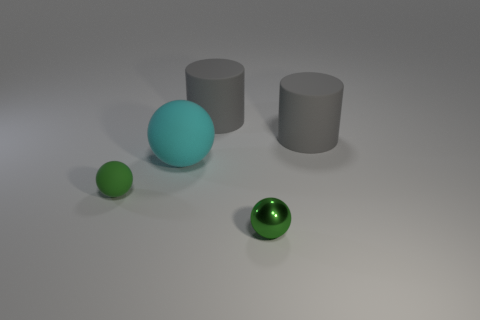Is there anything else that has the same material as the large ball?
Your answer should be very brief. Yes. How big is the sphere that is both in front of the big cyan object and right of the small matte object?
Make the answer very short. Small. What material is the tiny ball that is the same color as the tiny rubber object?
Ensure brevity in your answer.  Metal. What number of big matte things have the same color as the tiny rubber sphere?
Keep it short and to the point. 0. Is the number of large cylinders that are left of the big sphere the same as the number of purple cylinders?
Ensure brevity in your answer.  Yes. The small metal thing has what color?
Provide a succinct answer. Green. There is a green sphere that is the same material as the cyan ball; what is its size?
Offer a terse response. Small. What color is the other small ball that is made of the same material as the cyan ball?
Offer a very short reply. Green. Are there any green spheres of the same size as the cyan rubber sphere?
Give a very brief answer. No. There is a large cyan object that is the same shape as the green shiny thing; what is it made of?
Your answer should be very brief. Rubber. 